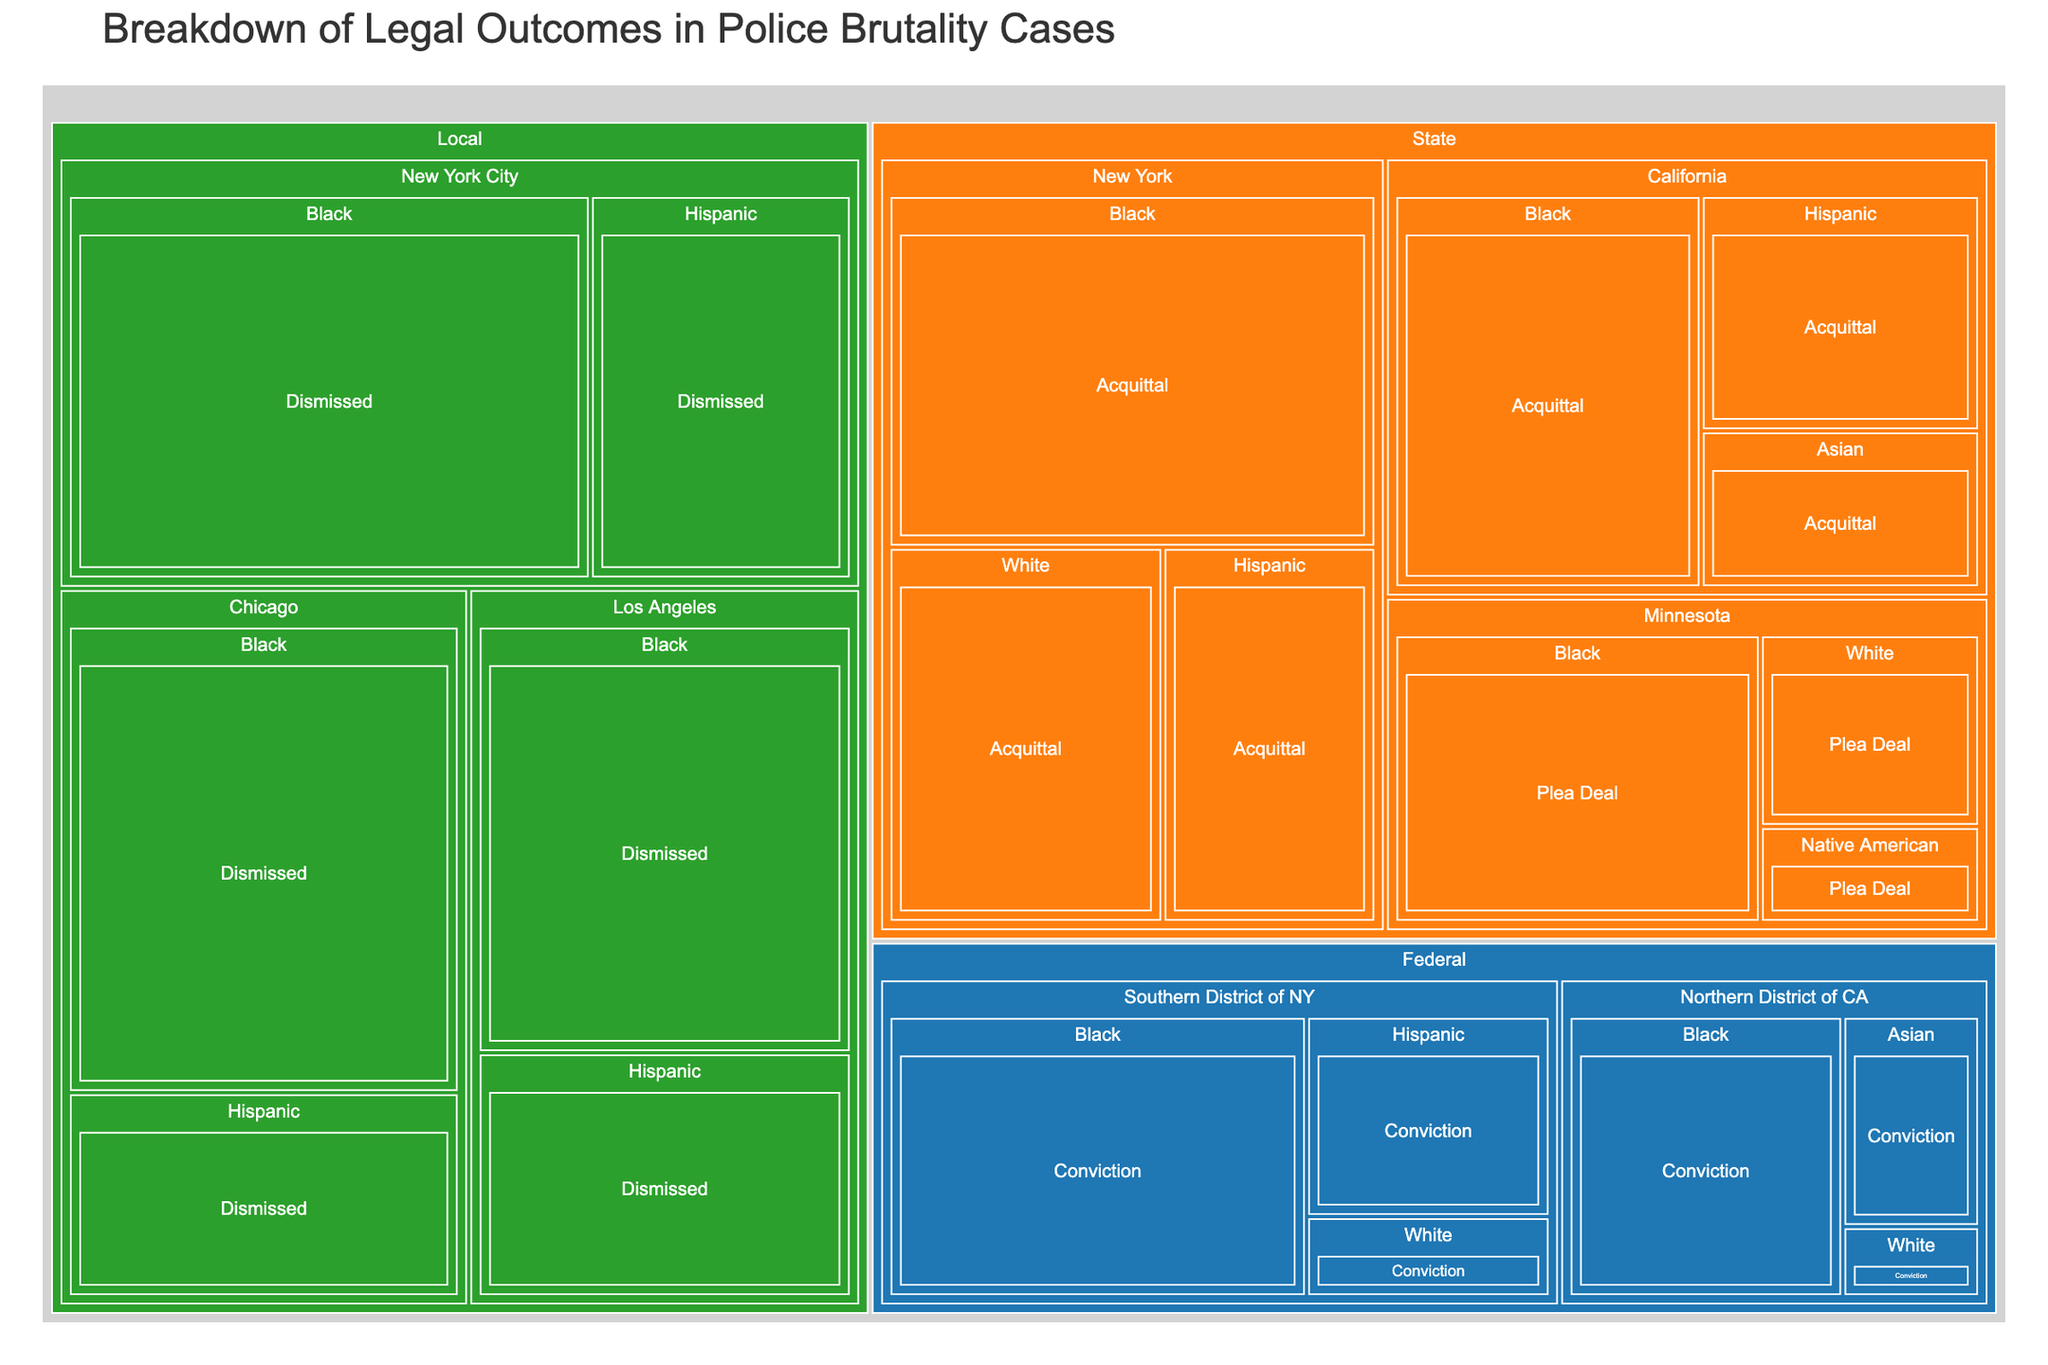What is the title of the plot? The title of the plot is provided at the top of the treemap, which is typically a descriptive text summarizing the content of the figure. Here, it describes the breakdown of legal outcomes in police brutality cases by race and jurisdiction.
Answer: Breakdown of Legal Outcomes in Police Brutality Cases How many cases of convictions involving Black individuals are reported in the Southern District of NY? To find the number of cases, locate the Federal category, then Southern District of NY jurisdiction, and finally the Black race segment. The cases are labeled directly in the figure.
Answer: 12 Which jurisdiction within the State category has the highest number of acquittals involving Black individuals? Navigate to the State category and look at the jurisdictions listed under it. Compare the number of cases for Black individuals in each jurisdiction. New York and California have data points; you'll find the larger number.
Answer: New York How do the number of acquittals for Hispanic individuals in New York and California compare? Go to the State category, and then compare the Hispanic acquittal segments within the New York and California jurisdictions. Count the cases listed for each.
Answer: New York has more (7 vs. 6) What is the total number of dismissed cases involving Black individuals in all jurisdictions? Add the number of dismissed cases for Black individuals across all jurisdictions in the Local category. Check New York City, Los Angeles, and Chicago sections.
Answer: 18 + 14 + 16 = 48 Which race in the Federal, Northern District of CA category has the fewest convictions? Within the Federal category, find the Northern District of CA and check the race segments for the number of cases. Compare the counts to identify the smallest.
Answer: White Calculate the difference in the number of plea deals between Black and White individuals in Minnesota. Look at the State category, then at Minnesota jurisdiction. Note the number of plea deals for Black and White individuals and subtract the smaller number from the larger one.
Answer: 10 - 4 = 6 What color is used to represent the State category in the treemap? The treemap uses distinct colors for each category, which helps in visually distinguishing them. The color used for the State category can be identified by looking at any segment under this grouping.
Answer: Orange Which legal outcome has the highest number of cases involving Hispanic individuals, and what is that number? Review all segments involving Hispanic individuals across different categories and jurisdictions. Determine which legal outcome (Conviction, Acquittal, Dismissed, Plea Deal) has the highest number of cases.
Answer: Dismissed with 9 cases in New York City How many jurisdictions have reported data for Black individuals in State category with any outcome? In the State category, count the unique jurisdictions (New York, California, Minnesota) that have plotted data points for Black individuals with any legal outcome (Acquittal, Plea Deal).
Answer: 3 